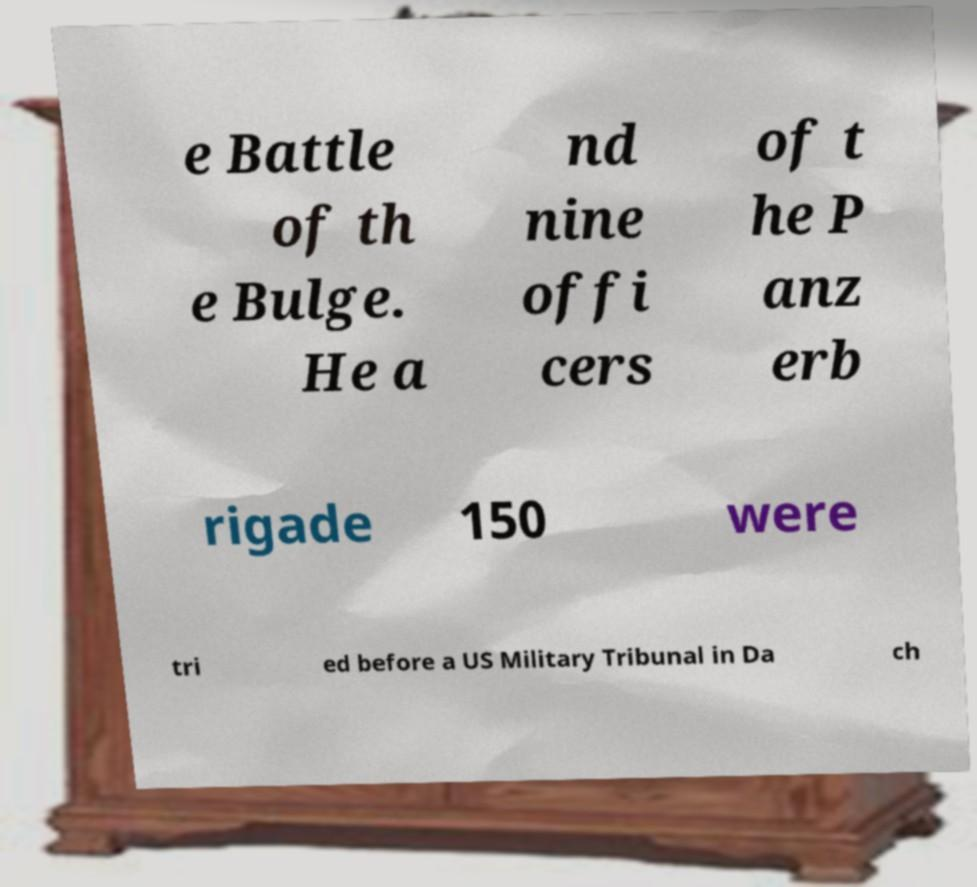For documentation purposes, I need the text within this image transcribed. Could you provide that? e Battle of th e Bulge. He a nd nine offi cers of t he P anz erb rigade 150 were tri ed before a US Military Tribunal in Da ch 